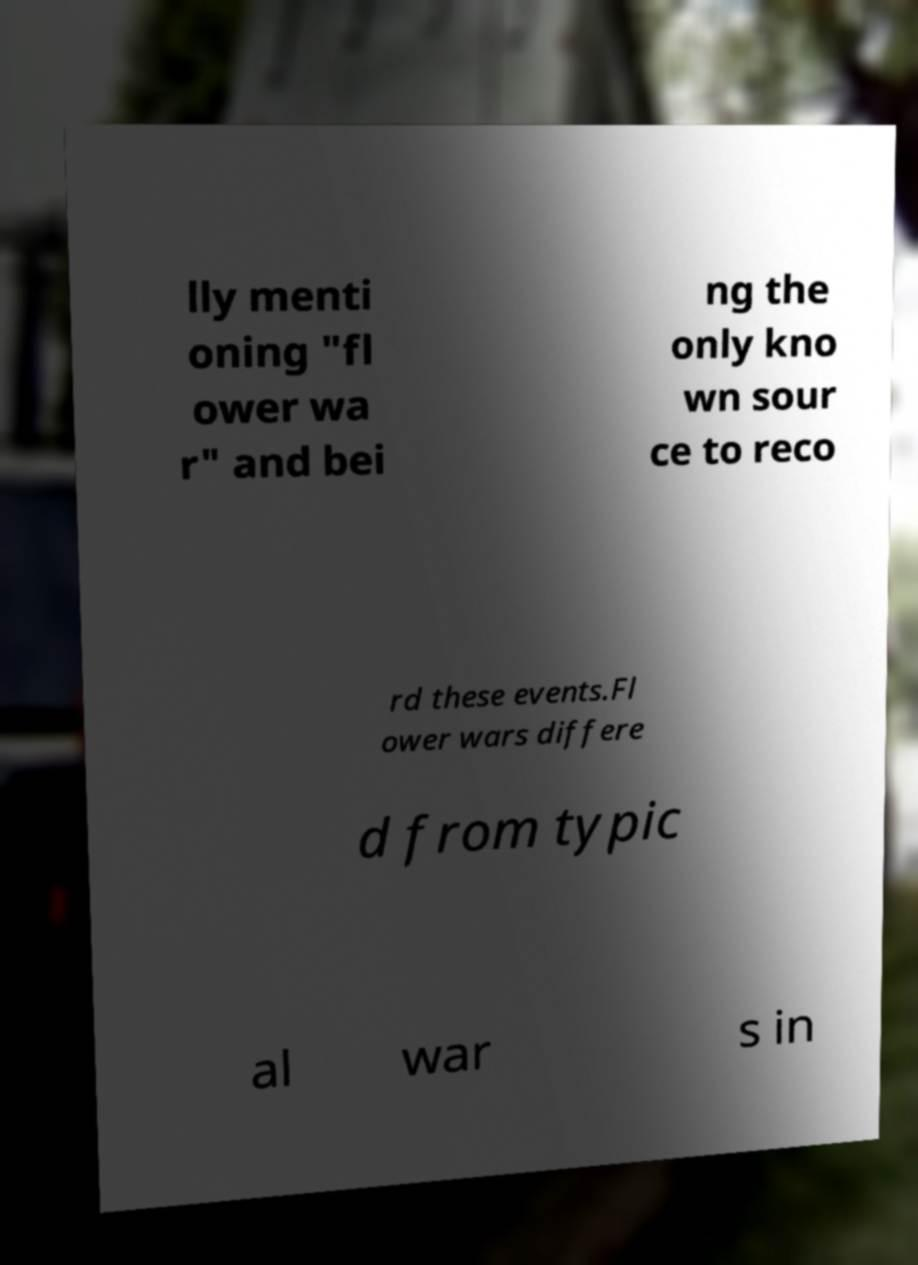Please read and relay the text visible in this image. What does it say? lly menti oning "fl ower wa r" and bei ng the only kno wn sour ce to reco rd these events.Fl ower wars differe d from typic al war s in 